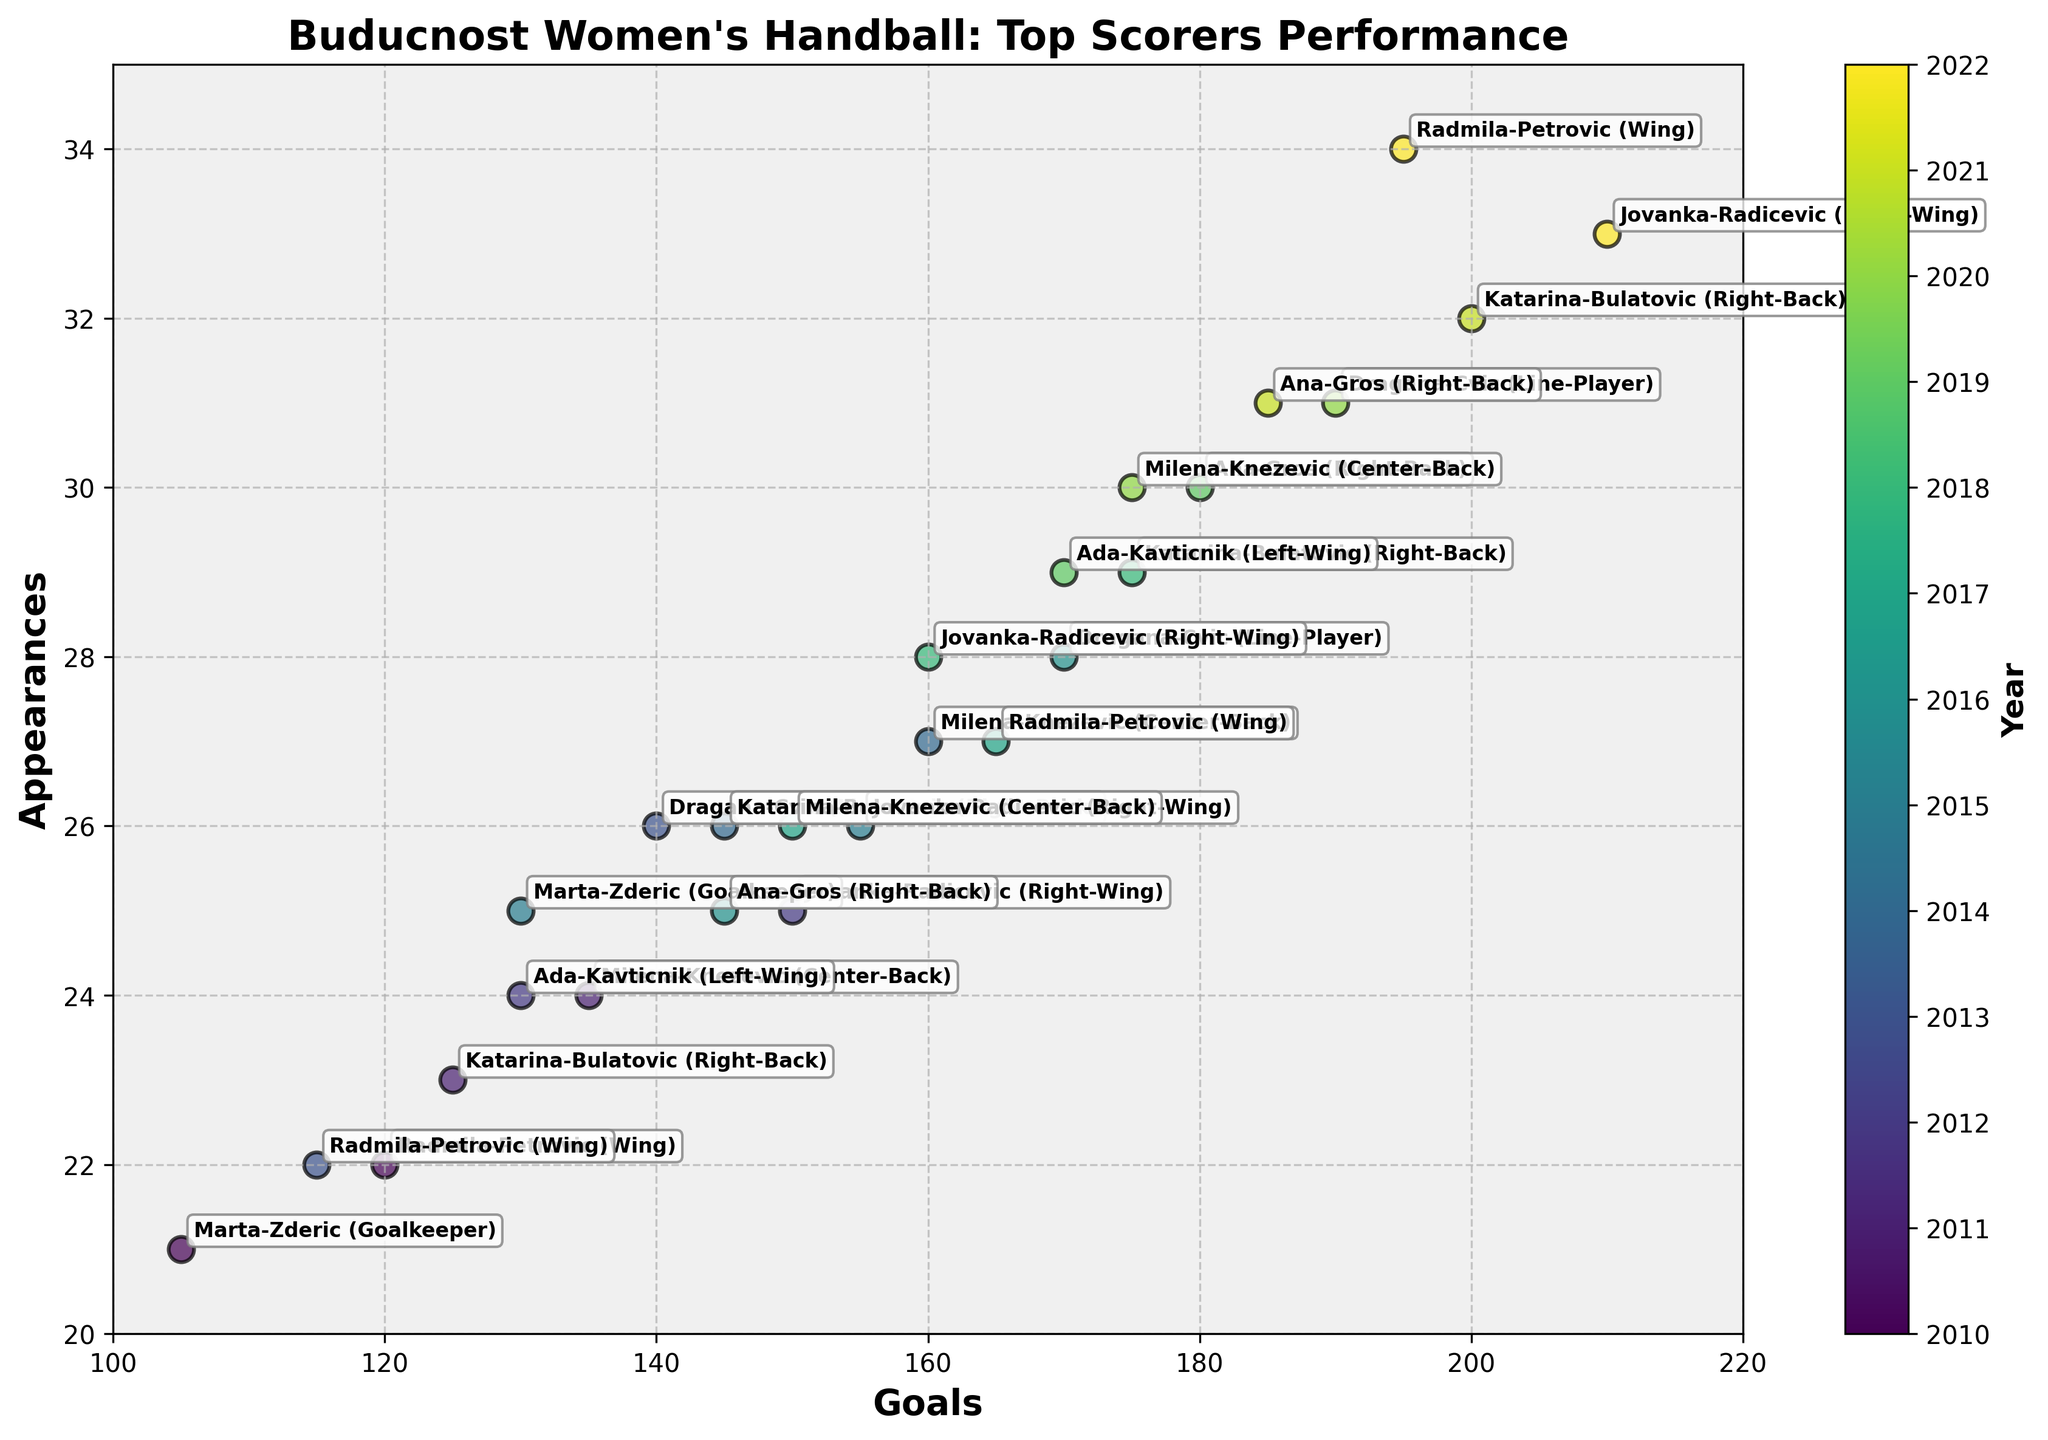How many players were annotated in the year 2012? In the year 2012, there are two players shown in the figure: Jovanka-Radicevic and Ada-Kavticnik.
Answer: 2 Which player had the highest number of appearances? Dragana-Cvic in 2020 had the highest number of appearances with 31.
Answer: Dragana-Cvic Which year had the player with the most goals? In 2022, Jovanka-Radicevic had the most goals with 210.
Answer: 2022 How many total goals were scored by Radmila-Petrovic during all the annotated years? Radmila-Petrovic scored 120 goals in 2010, 115 in 2013, 165 in 2017, and 195 in 2022. Summing these gives 595 goals.
Answer: 595 Who had more appearances in 2015: Jovanka Radicevic or Marta Zderic? In 2015, both Jovanka Radicevic and Marta Zderic had 26 and 25 appearances respectively. Jovanka Radicevic had more appearances.
Answer: Jovanka Radicevic Which player had the most consistent appearances over multiple years? Milena-Knezevic had appearances ranging from 24 to 30 over her four annotated years (2011, 2014, 2017, 2020), indicating high consistency.
Answer: Milena-Knezevic During which year did Katarina-Bulatovic score the highest number of goals? Katarina-Bulatovic scored the highest number of goals in 2021 with 200 goals.
Answer: 2021 How does the trend in Ana-Gros's scoring change from 2016 to 2021? Ana-Gros's trend shows an increase: 145 goals in 2016, 180 in 2019, and 185 in 2021. This indicates a general upward trend in her scoring.
Answer: Upward trend Compare the performance of goalkeepers in terms of goals and appearances. Marta Zderic's performances are in 2010 (105 goals, 21 appearances), and 2015 (130 goals, 25 appearances).
Answer: Marta Zderic scored more goals and had higher appearances in 2015 Which position had the highest individual goal score in any given year? In 2022, Jovanka-Radicevic as a Right-Wing had the highest individual goal score with 210 goals.
Answer: Right-Wing 